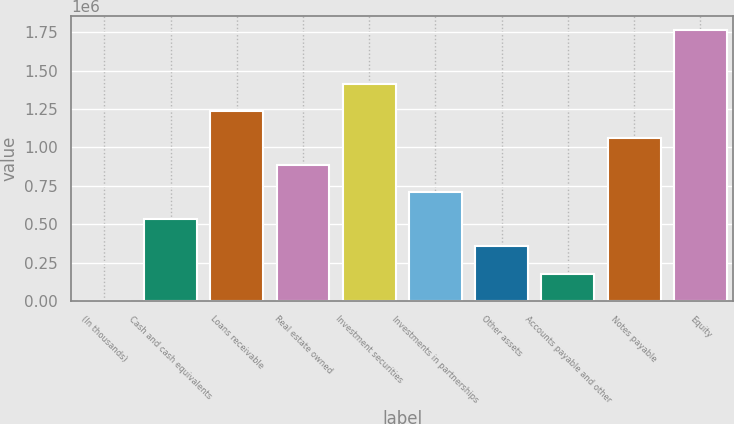<chart> <loc_0><loc_0><loc_500><loc_500><bar_chart><fcel>(In thousands)<fcel>Cash and cash equivalents<fcel>Loans receivable<fcel>Real estate owned<fcel>Investment securities<fcel>Investments in partnerships<fcel>Other assets<fcel>Accounts payable and other<fcel>Notes payable<fcel>Equity<nl><fcel>2014<fcel>531783<fcel>1.23814e+06<fcel>884963<fcel>1.41473e+06<fcel>708373<fcel>355194<fcel>178604<fcel>1.06155e+06<fcel>1.76791e+06<nl></chart> 